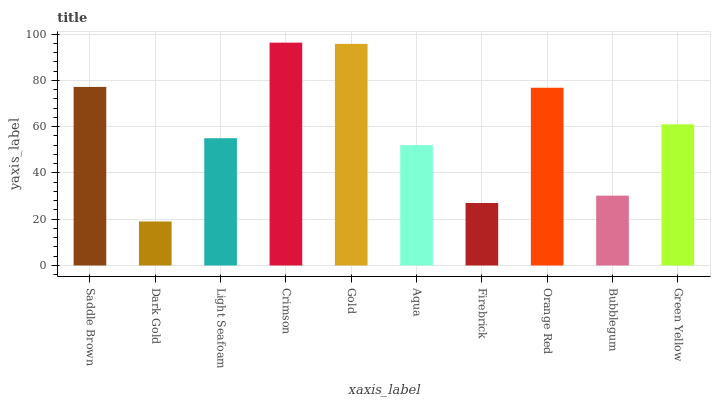Is Light Seafoam the minimum?
Answer yes or no. No. Is Light Seafoam the maximum?
Answer yes or no. No. Is Light Seafoam greater than Dark Gold?
Answer yes or no. Yes. Is Dark Gold less than Light Seafoam?
Answer yes or no. Yes. Is Dark Gold greater than Light Seafoam?
Answer yes or no. No. Is Light Seafoam less than Dark Gold?
Answer yes or no. No. Is Green Yellow the high median?
Answer yes or no. Yes. Is Light Seafoam the low median?
Answer yes or no. Yes. Is Dark Gold the high median?
Answer yes or no. No. Is Crimson the low median?
Answer yes or no. No. 